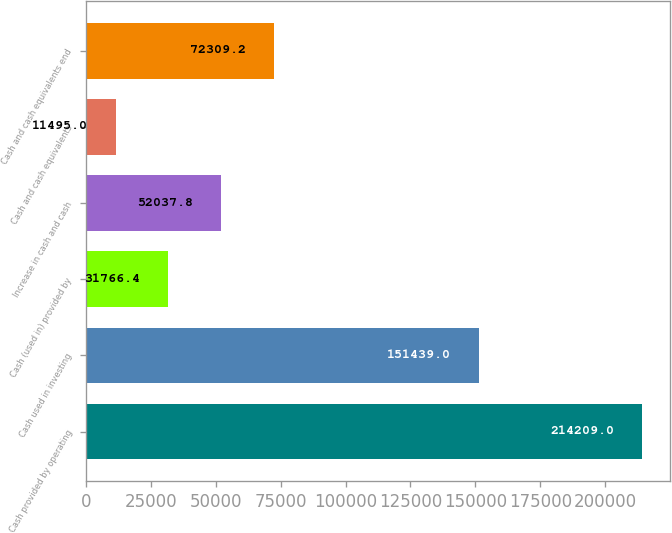Convert chart. <chart><loc_0><loc_0><loc_500><loc_500><bar_chart><fcel>Cash provided by operating<fcel>Cash used in investing<fcel>Cash (used in) provided by<fcel>Increase in cash and cash<fcel>Cash and cash equivalents<fcel>Cash and cash equivalents end<nl><fcel>214209<fcel>151439<fcel>31766.4<fcel>52037.8<fcel>11495<fcel>72309.2<nl></chart> 